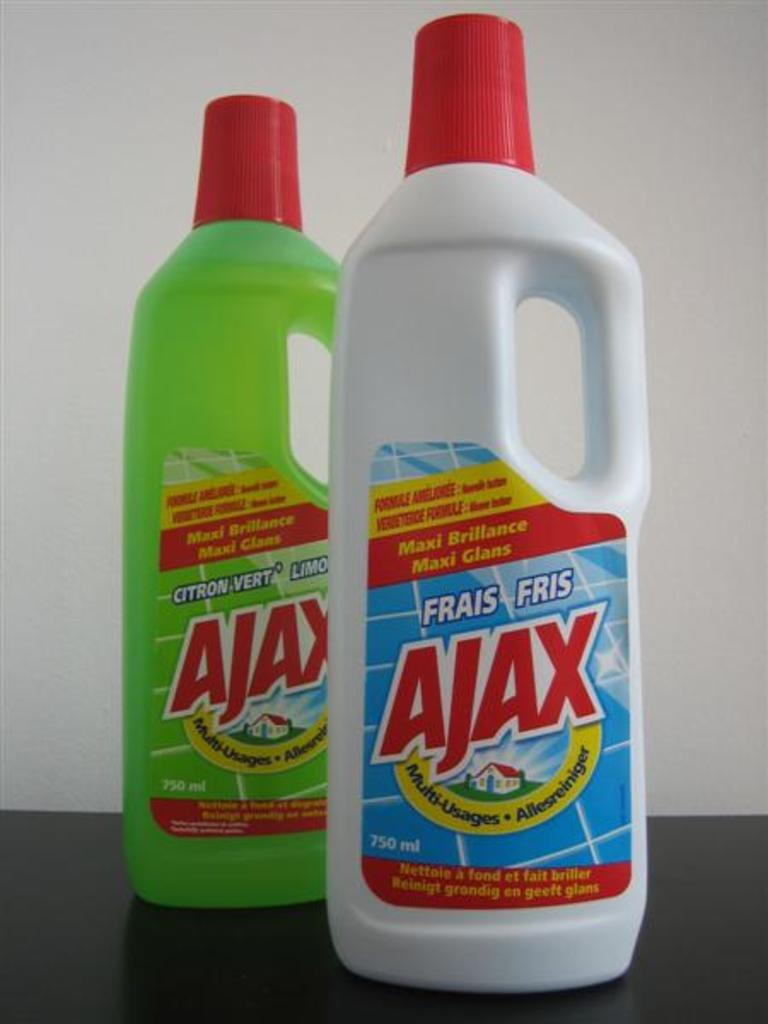<image>
Create a compact narrative representing the image presented. Two bottles of liquid used for cleaning by a brand called Ajax. 